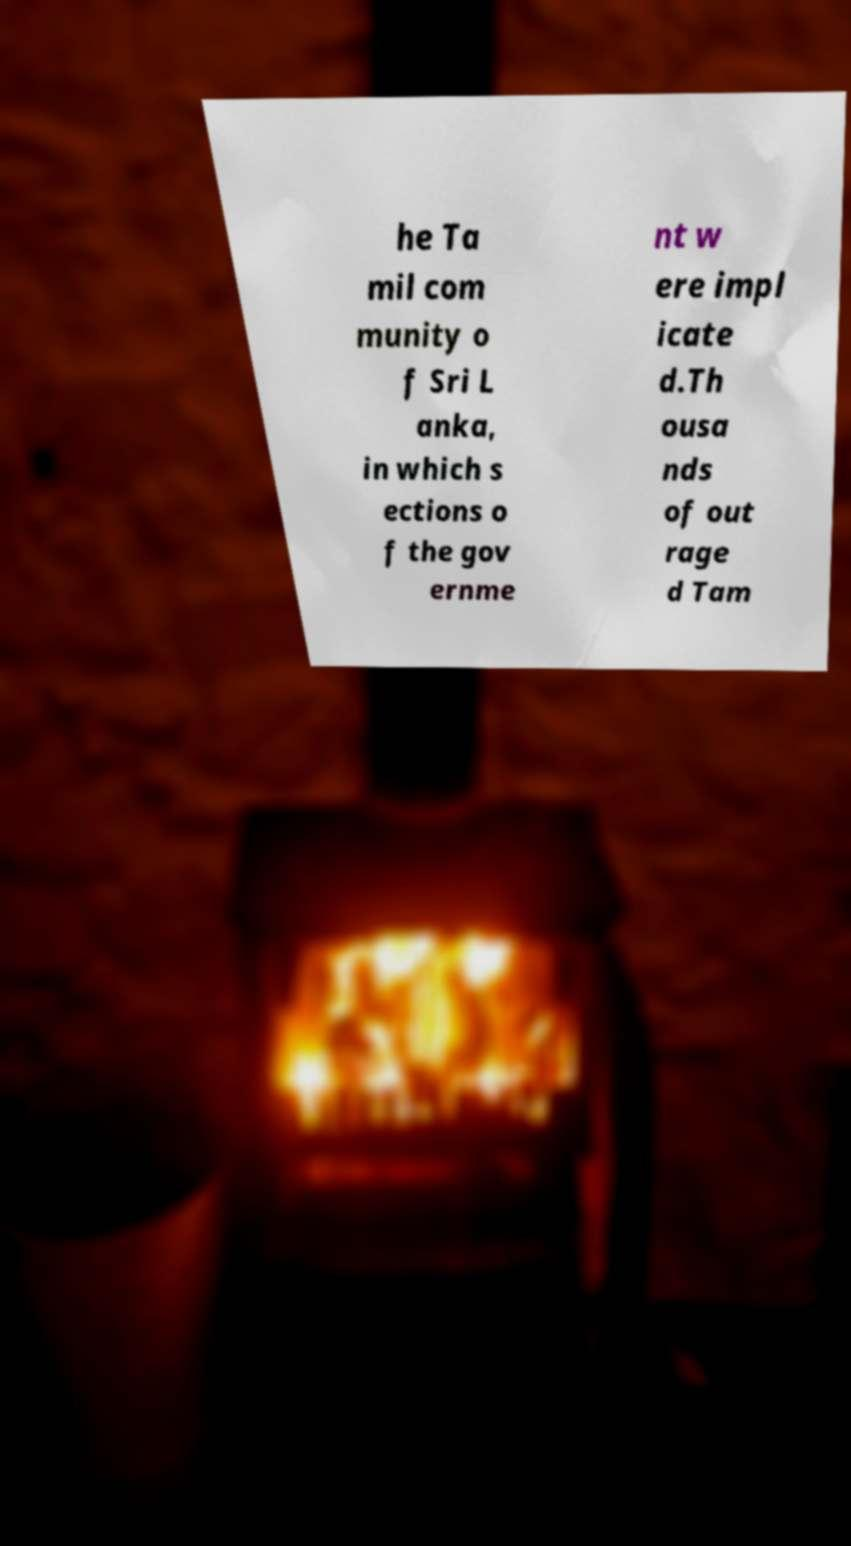Can you accurately transcribe the text from the provided image for me? he Ta mil com munity o f Sri L anka, in which s ections o f the gov ernme nt w ere impl icate d.Th ousa nds of out rage d Tam 